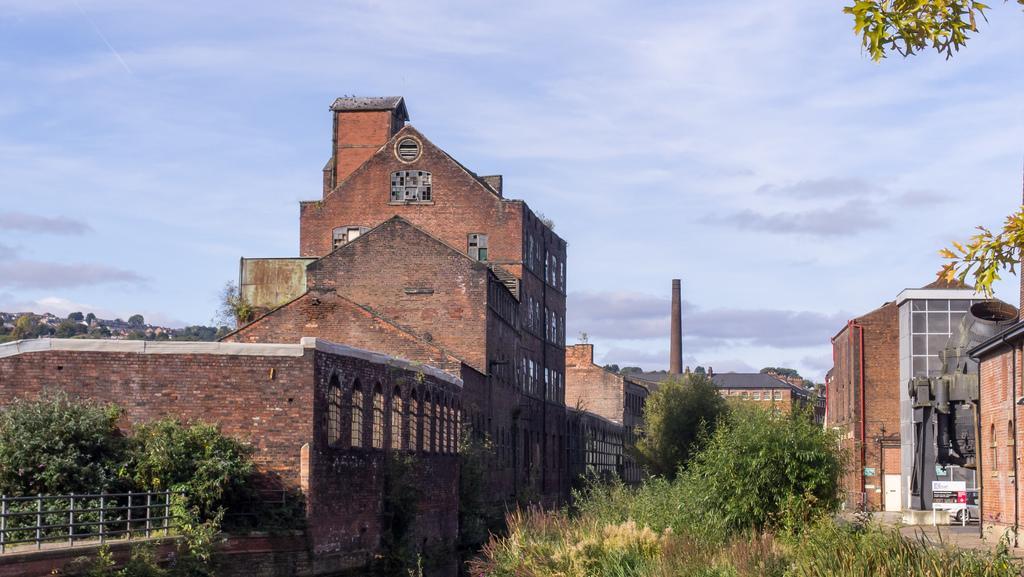Can you describe this image briefly? In this image, we can see a few houses. There are a few plants. We can see the fence on the left. We can see a concrete mixer and a board with some text. We can see a pole. There are a few trees. We can also see the sky with clouds. 